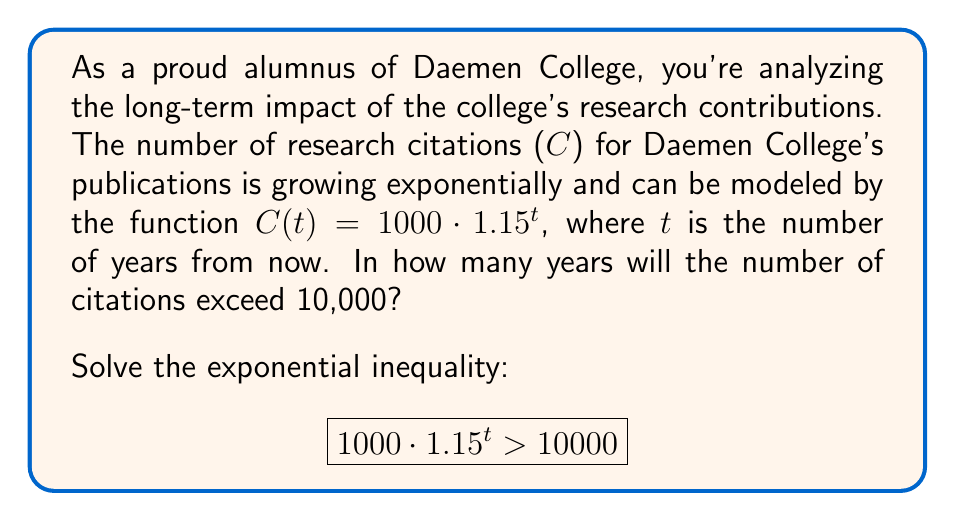Solve this math problem. Let's solve this step-by-step:

1) First, we start with the inequality:
   $$1000 \cdot 1.15^t > 10000$$

2) Divide both sides by 1000:
   $$1.15^t > 10$$

3) Take the natural logarithm of both sides:
   $$\ln(1.15^t) > \ln(10)$$

4) Use the logarithm property $\ln(a^b) = b\ln(a)$:
   $$t \cdot \ln(1.15) > \ln(10)$$

5) Divide both sides by $\ln(1.15)$:
   $$t > \frac{\ln(10)}{\ln(1.15)}$$

6) Calculate the right side:
   $$t > \frac{\ln(10)}{\ln(1.15)} \approx 16.27$$

7) Since t represents years and must be a whole number, we round up to the next integer.
Answer: The number of citations will exceed 10,000 in 17 years. 